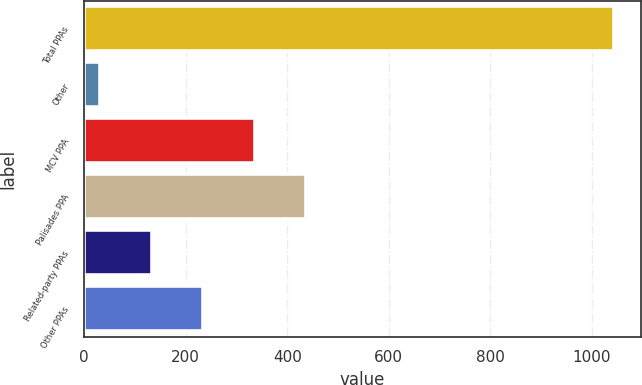Convert chart to OTSL. <chart><loc_0><loc_0><loc_500><loc_500><bar_chart><fcel>Total PPAs<fcel>Other<fcel>MCV PPA<fcel>Palisades PPA<fcel>Related-party PPAs<fcel>Other PPAs<nl><fcel>1044<fcel>32<fcel>335.6<fcel>436.8<fcel>133.2<fcel>234.4<nl></chart> 